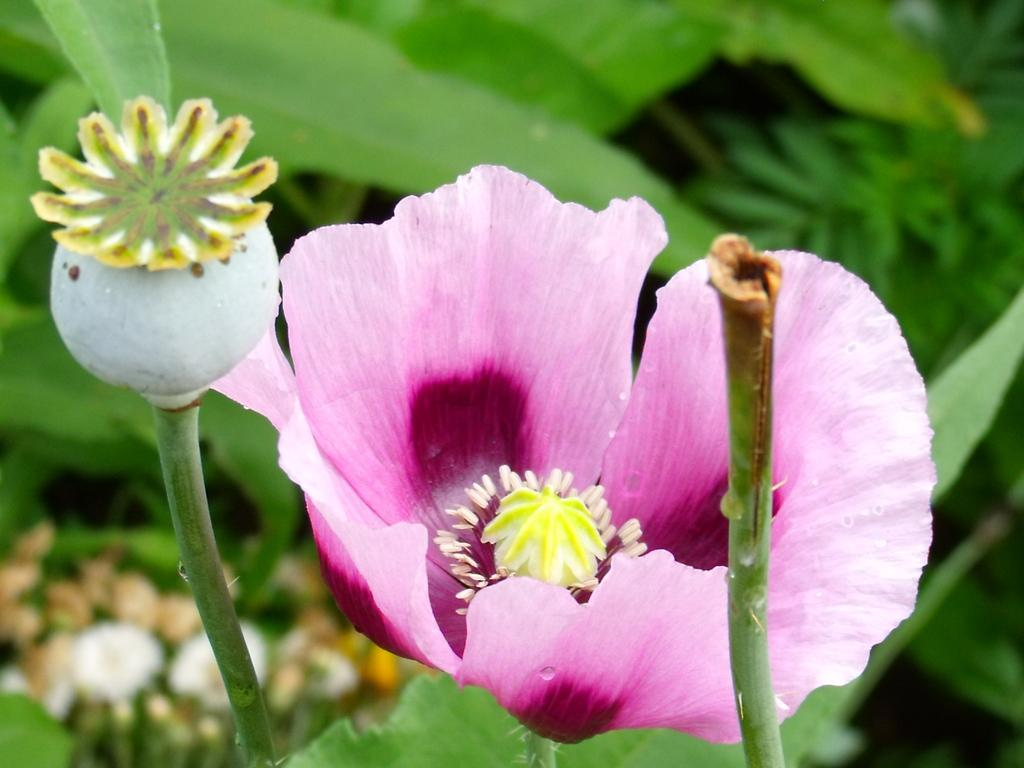What type of flower is present in the image? There is a pink color flower in the image. What else can be seen in the image besides the flower? Leaves are visible in the image. How are the leaves depicted in the image? The leaves are blurred in the image. What type of honey can be seen dripping from the spoon in the image? There is no spoon or honey present in the image; it only features a pink color flower and blurred leaves. 